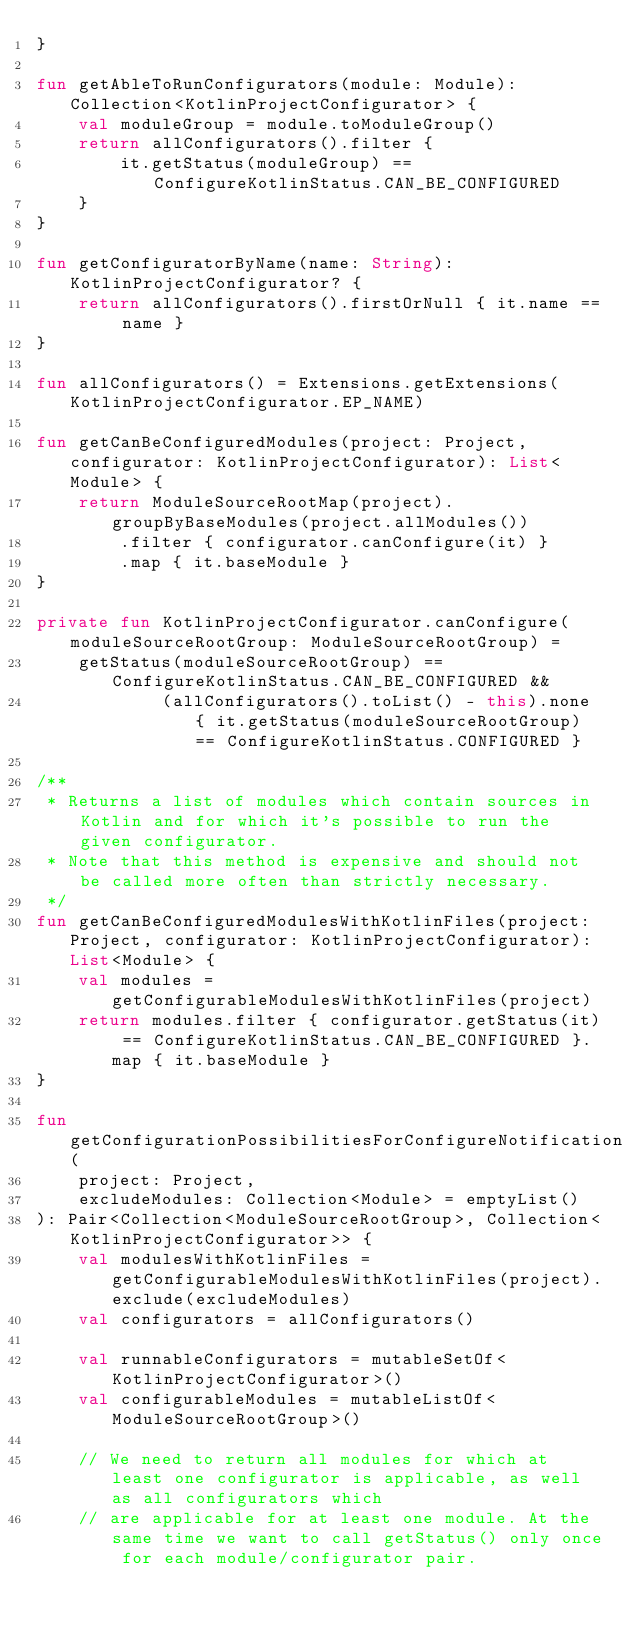<code> <loc_0><loc_0><loc_500><loc_500><_Kotlin_>}

fun getAbleToRunConfigurators(module: Module): Collection<KotlinProjectConfigurator> {
    val moduleGroup = module.toModuleGroup()
    return allConfigurators().filter {
        it.getStatus(moduleGroup) == ConfigureKotlinStatus.CAN_BE_CONFIGURED
    }
}

fun getConfiguratorByName(name: String): KotlinProjectConfigurator? {
    return allConfigurators().firstOrNull { it.name == name }
}

fun allConfigurators() = Extensions.getExtensions(KotlinProjectConfigurator.EP_NAME)

fun getCanBeConfiguredModules(project: Project, configurator: KotlinProjectConfigurator): List<Module> {
    return ModuleSourceRootMap(project).groupByBaseModules(project.allModules())
        .filter { configurator.canConfigure(it) }
        .map { it.baseModule }
}

private fun KotlinProjectConfigurator.canConfigure(moduleSourceRootGroup: ModuleSourceRootGroup) =
    getStatus(moduleSourceRootGroup) == ConfigureKotlinStatus.CAN_BE_CONFIGURED &&
            (allConfigurators().toList() - this).none { it.getStatus(moduleSourceRootGroup) == ConfigureKotlinStatus.CONFIGURED }

/**
 * Returns a list of modules which contain sources in Kotlin and for which it's possible to run the given configurator.
 * Note that this method is expensive and should not be called more often than strictly necessary.
 */
fun getCanBeConfiguredModulesWithKotlinFiles(project: Project, configurator: KotlinProjectConfigurator): List<Module> {
    val modules = getConfigurableModulesWithKotlinFiles(project)
    return modules.filter { configurator.getStatus(it) == ConfigureKotlinStatus.CAN_BE_CONFIGURED }.map { it.baseModule }
}

fun getConfigurationPossibilitiesForConfigureNotification(
    project: Project,
    excludeModules: Collection<Module> = emptyList()
): Pair<Collection<ModuleSourceRootGroup>, Collection<KotlinProjectConfigurator>> {
    val modulesWithKotlinFiles = getConfigurableModulesWithKotlinFiles(project).exclude(excludeModules)
    val configurators = allConfigurators()

    val runnableConfigurators = mutableSetOf<KotlinProjectConfigurator>()
    val configurableModules = mutableListOf<ModuleSourceRootGroup>()

    // We need to return all modules for which at least one configurator is applicable, as well as all configurators which
    // are applicable for at least one module. At the same time we want to call getStatus() only once for each module/configurator pair.</code> 